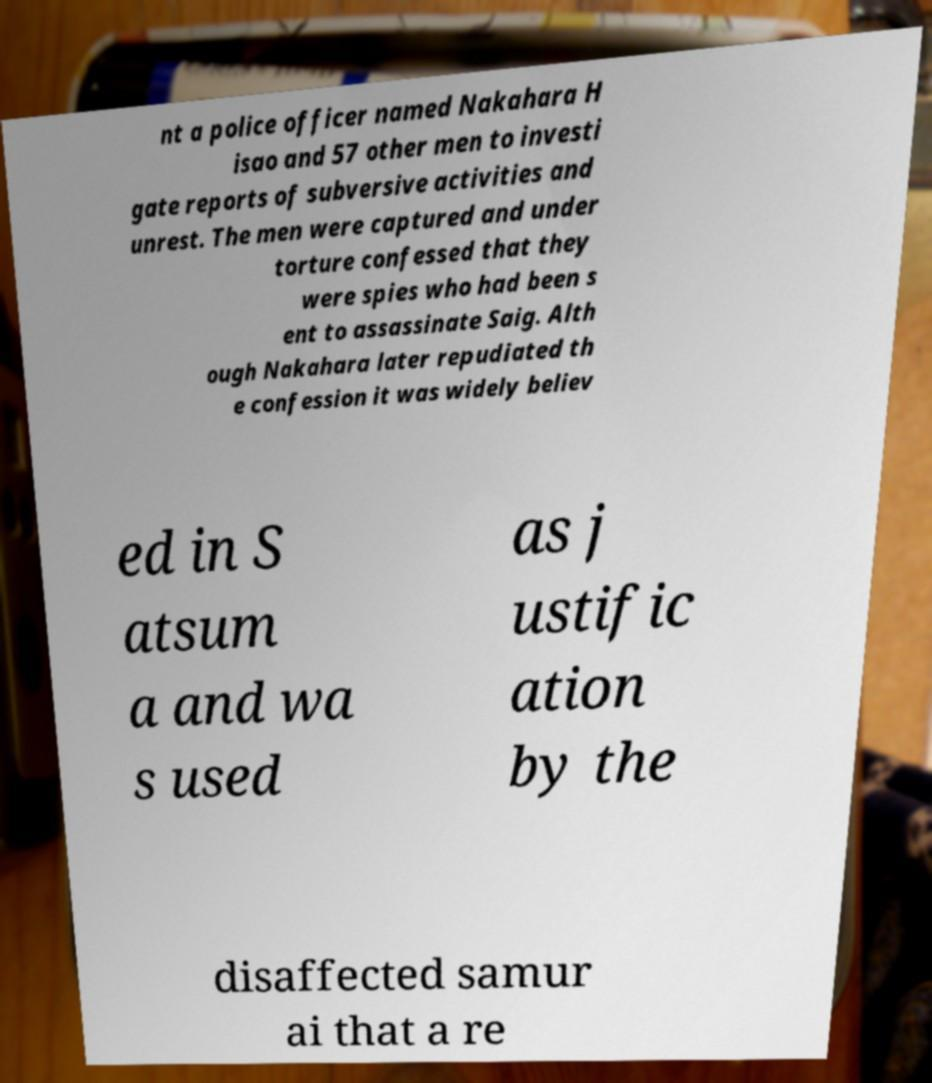Please read and relay the text visible in this image. What does it say? nt a police officer named Nakahara H isao and 57 other men to investi gate reports of subversive activities and unrest. The men were captured and under torture confessed that they were spies who had been s ent to assassinate Saig. Alth ough Nakahara later repudiated th e confession it was widely believ ed in S atsum a and wa s used as j ustific ation by the disaffected samur ai that a re 